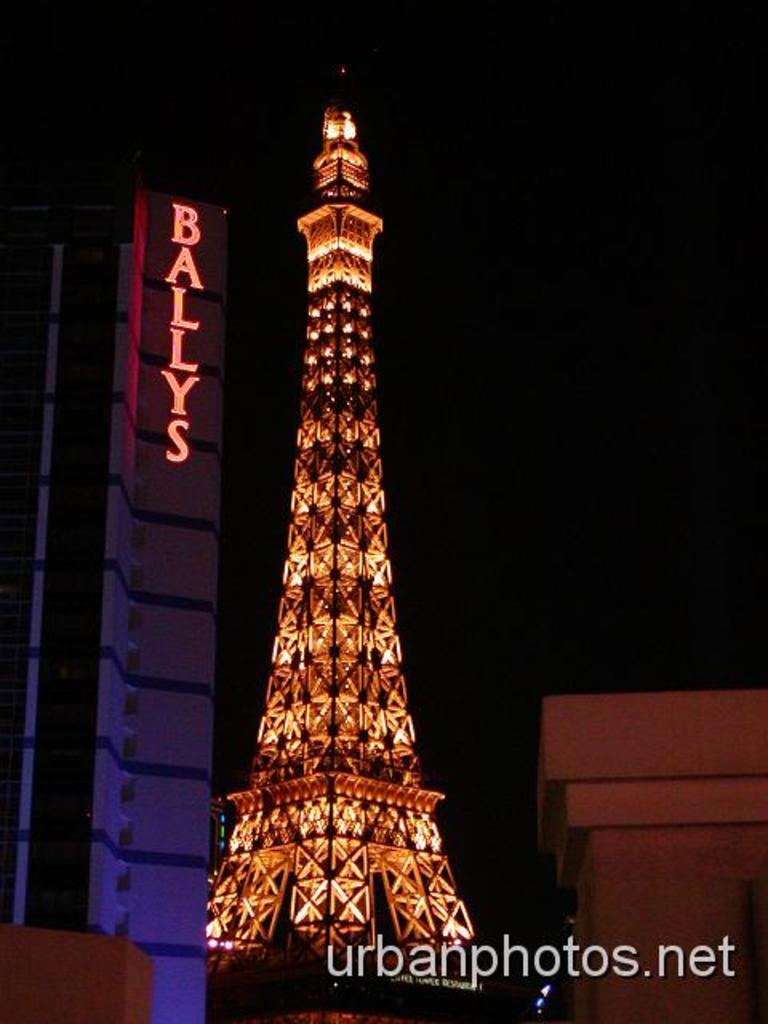What is the main structure in the image? There is a tower in the image. What other building can be seen in the image? There is a building on the left side of the image. Are there any words or letters visible on the building? Yes, there is text on the building. Where can additional text be found in the image? There is text in the bottom right corner of the image. How does the fog affect the visibility of the tower in the image? There is no fog present in the image, so it does not affect the visibility of the tower. 